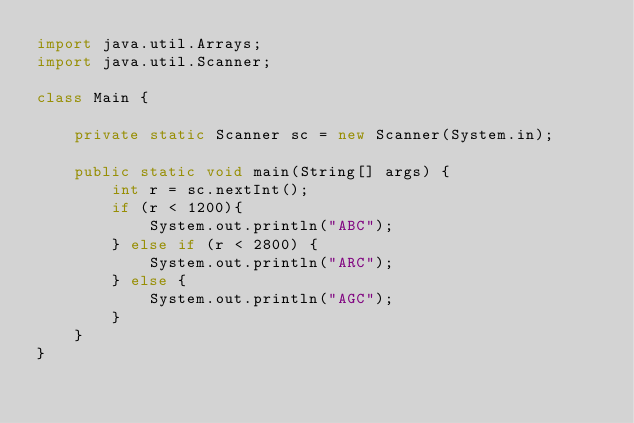<code> <loc_0><loc_0><loc_500><loc_500><_Java_>import java.util.Arrays;
import java.util.Scanner;

class Main {

    private static Scanner sc = new Scanner(System.in);

    public static void main(String[] args) {
        int r = sc.nextInt();
        if (r < 1200){
            System.out.println("ABC");
        } else if (r < 2800) {
            System.out.println("ARC");
        } else {
            System.out.println("AGC");
        }
    }
}</code> 